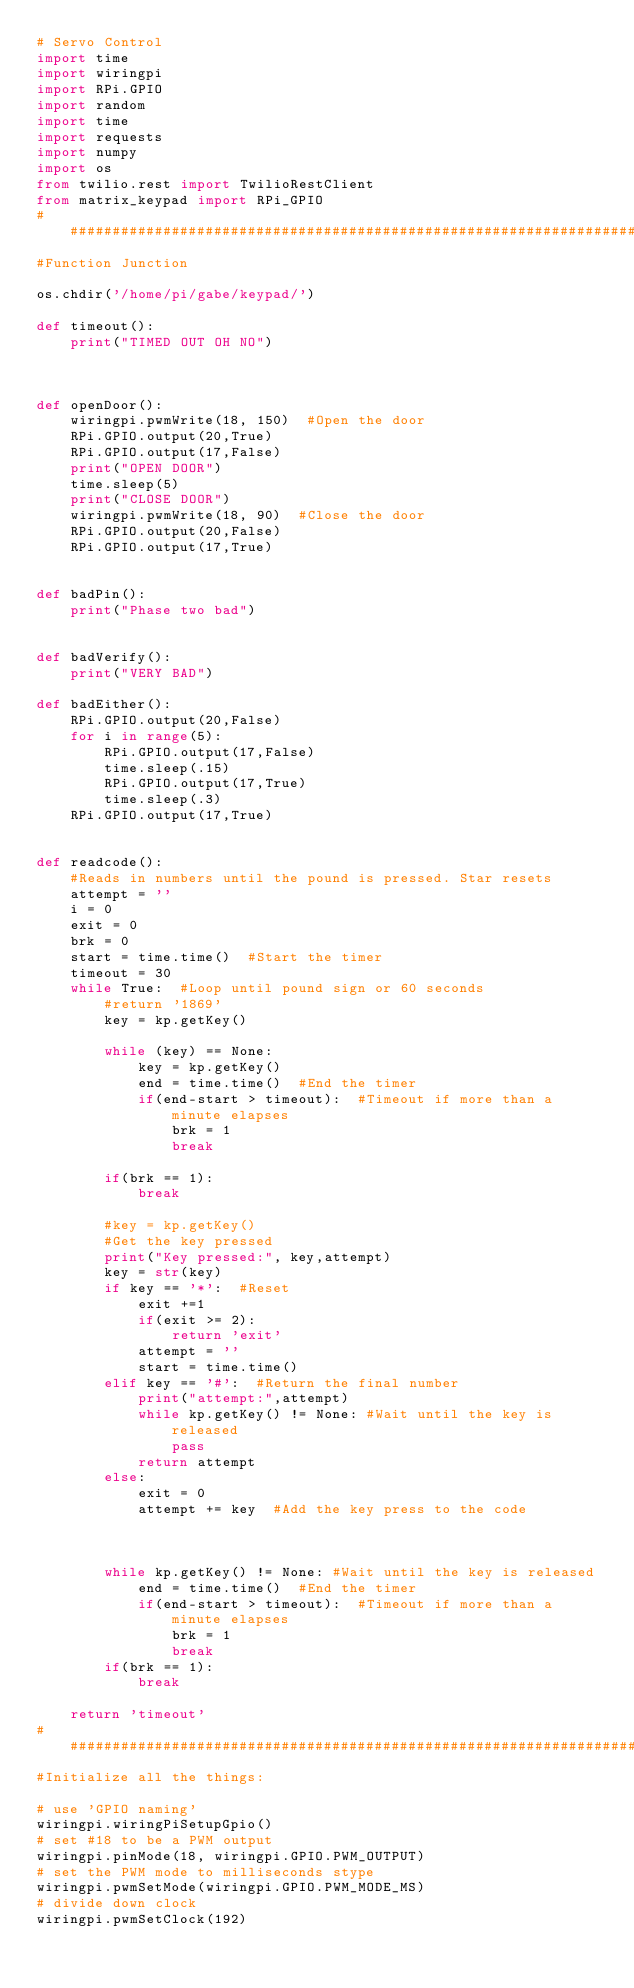<code> <loc_0><loc_0><loc_500><loc_500><_Python_># Servo Control
import time
import wiringpi
import RPi.GPIO
import random
import time
import requests
import numpy
import os
from twilio.rest import TwilioRestClient
from matrix_keypad import RPi_GPIO
########################################################################3
#Function Junction

os.chdir('/home/pi/gabe/keypad/')

def timeout():
    print("TIMED OUT OH NO")
    
    
    
def openDoor():
    wiringpi.pwmWrite(18, 150)  #Open the door
    RPi.GPIO.output(20,True)
    RPi.GPIO.output(17,False)
    print("OPEN DOOR")
    time.sleep(5)
    print("CLOSE DOOR")
    wiringpi.pwmWrite(18, 90)  #Close the door
    RPi.GPIO.output(20,False)
    RPi.GPIO.output(17,True)

    
def badPin():
    print("Phase two bad")
    
    
def badVerify():
    print("VERY BAD")
    
def badEither():
    RPi.GPIO.output(20,False)
    for i in range(5):
        RPi.GPIO.output(17,False)
        time.sleep(.15)
        RPi.GPIO.output(17,True)
        time.sleep(.3)
    RPi.GPIO.output(17,True)
    
    
def readcode():
    #Reads in numbers until the pound is pressed. Star resets
    attempt = ''
    i = 0
    exit = 0
    brk = 0
    start = time.time()  #Start the timer
    timeout = 30
    while True:  #Loop until pound sign or 60 seconds
        #return '1869'
        key = kp.getKey()
        
        while (key) == None:
            key = kp.getKey()
            end = time.time()  #End the timer
            if(end-start > timeout):  #Timeout if more than a minute elapses
                brk = 1
                break
                
        if(brk == 1):
            break
            
        #key = kp.getKey()
        #Get the key pressed
        print("Key pressed:", key,attempt)
        key = str(key)
        if key == '*':  #Reset
            exit +=1
            if(exit >= 2):
                return 'exit'
            attempt = ''
            start = time.time()
        elif key == '#':  #Return the final number
            print("attempt:",attempt)
            while kp.getKey() != None: #Wait until the key is released
                pass
            return attempt
        else:
            exit = 0
            attempt += key  #Add the key press to the code

        

        while kp.getKey() != None: #Wait until the key is released
            end = time.time()  #End the timer
            if(end-start > timeout):  #Timeout if more than a minute elapses
                brk = 1
                break
        if(brk == 1):
            break
    
    return 'timeout'
##########################################################################################
#Initialize all the things:

# use 'GPIO naming'
wiringpi.wiringPiSetupGpio()
# set #18 to be a PWM output
wiringpi.pinMode(18, wiringpi.GPIO.PWM_OUTPUT)
# set the PWM mode to milliseconds stype
wiringpi.pwmSetMode(wiringpi.GPIO.PWM_MODE_MS)
# divide down clock
wiringpi.pwmSetClock(192)</code> 